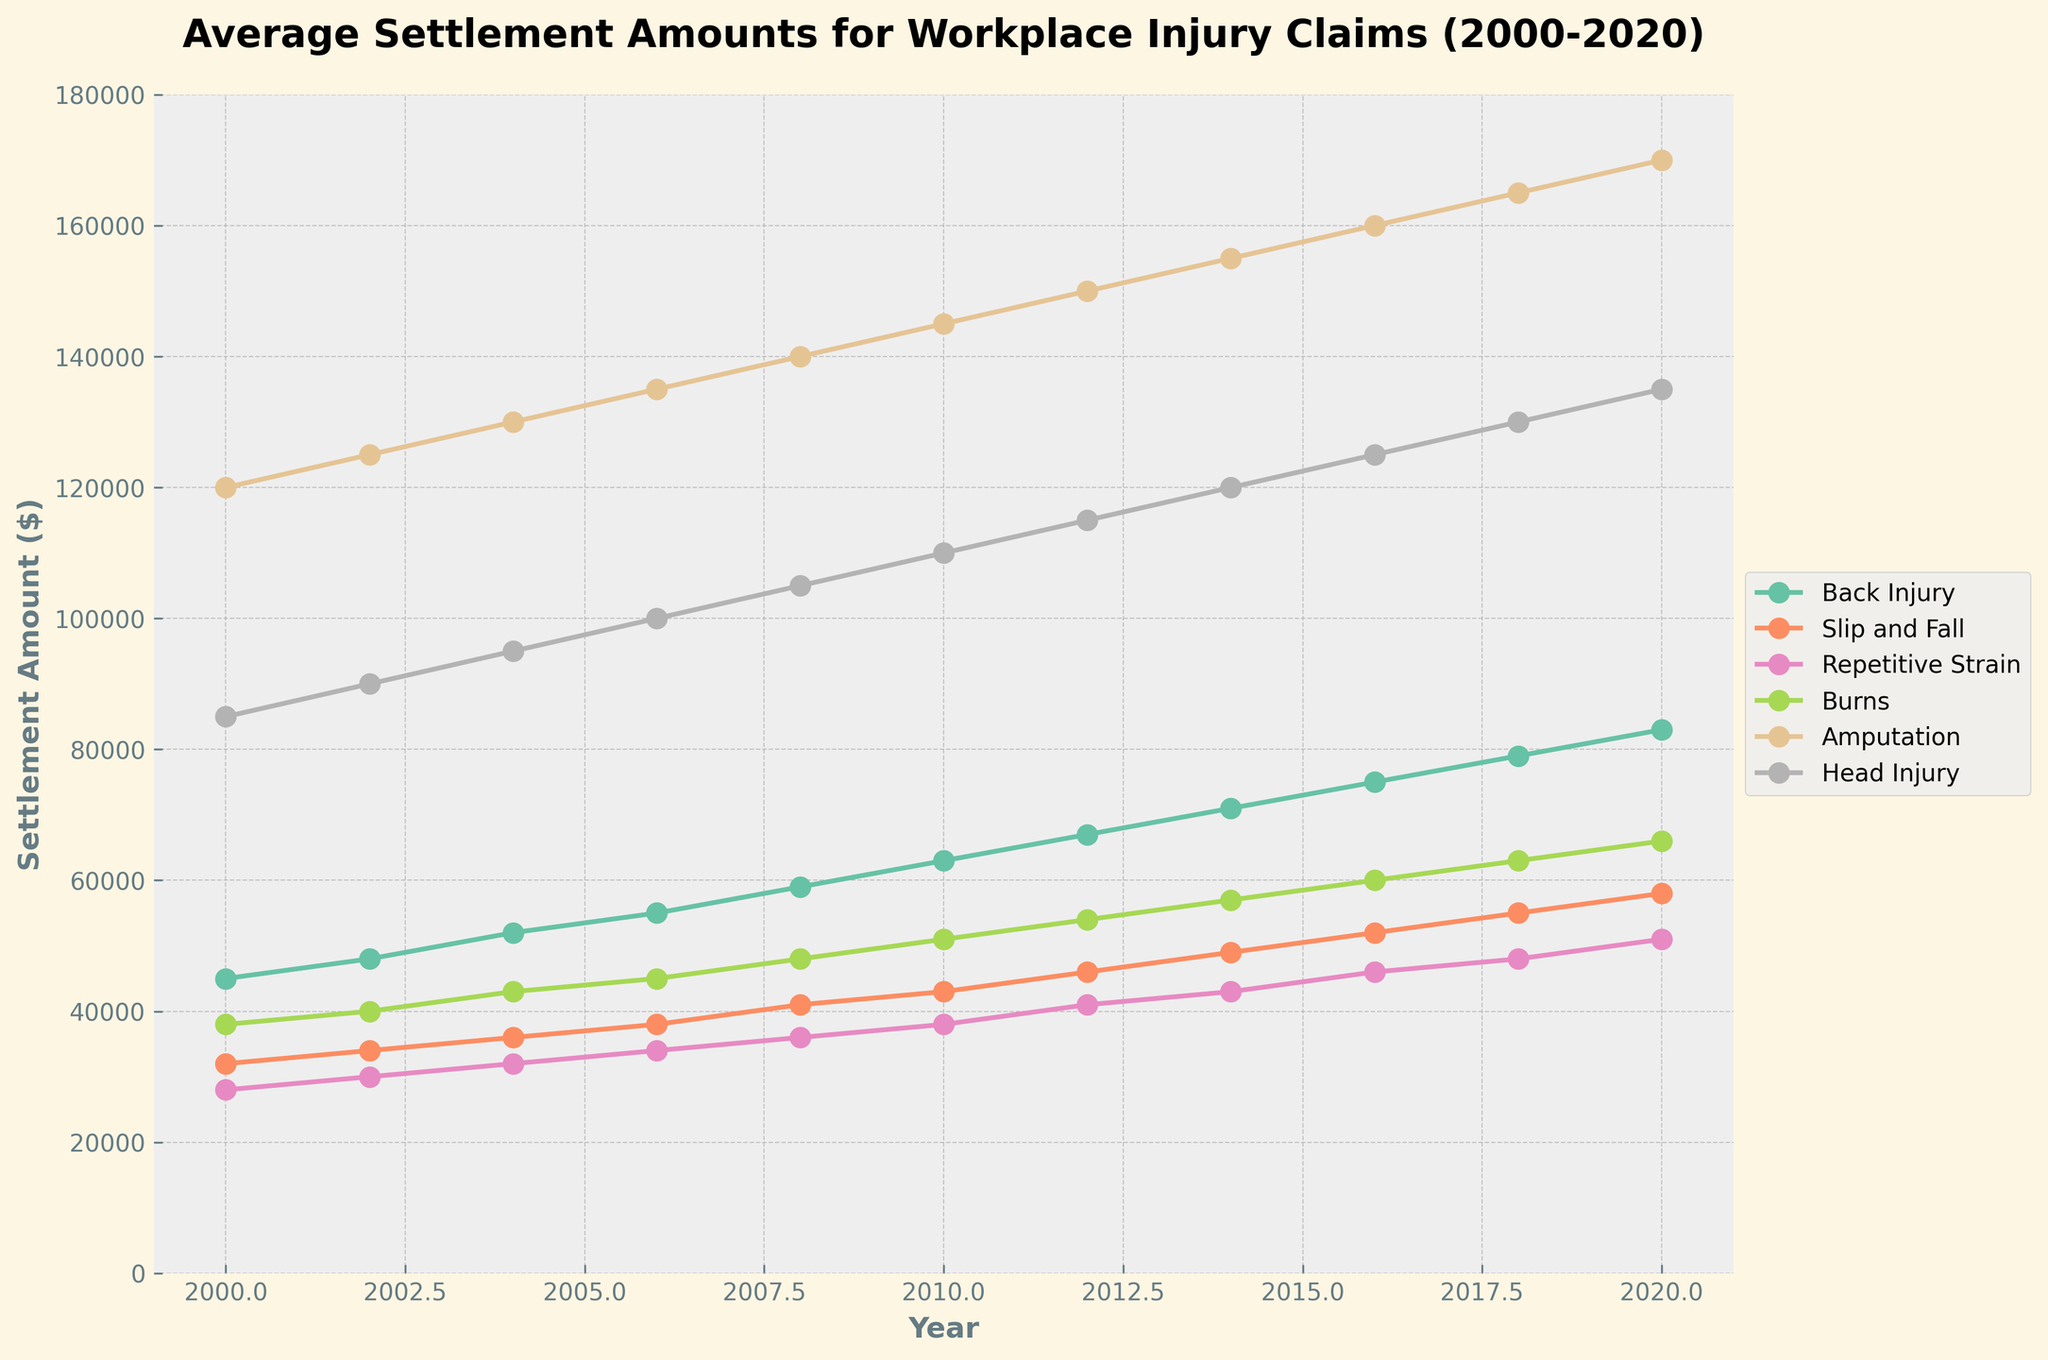Which type of injury had the highest average settlement amount in 2020? In 2020, look at the lines to identify the highest point. The Amputation category is the highest.
Answer: Amputation How did the average settlement amount for Slip and Fall injuries change from 2010 to 2020? Find the values for Slip and Fall in 2010 and 2020. In 2010, it was $43,000, and in 2020, it was $58,000. The change is $58,000 - $43,000 = $15,000.
Answer: Increased by $15,000 Which injury type had the least increase in average settlement amounts between 2000 and 2020? Calculate the difference between 2020 and 2000 for each injury type. The differences are: Back Injury: $83,000 - $45,000 = $38,000; Slip and Fall: $58,000 - $32,000 = $26,000; Repetitive Strain: $51,000 - $28,000 = $23,000; Burns: $66,000 - $38,000 = $28,000; Amputation: $170,000 - $120,000 = $50,000; Head Injury: $135,000 - $85,000 = $50,000. Repetitive Strain had the smallest increase ($23,000).
Answer: Repetitive Strain What is the average settlement amount for Back Injury claims over the entire period? Find the values for Back Injury and calculate the average: ($45,000 + $48,000 + $52,000 + $55,000 + $59,000 + $63,000 + $67,000 + $71,000 + $75,000 + $79,000 + $83,000) / 11 = $62,000.
Answer: $62,000 Compare the trends of Back Injury and Head Injury claims from 2000 to 2020. Both Back Injury and Head Injury show an increasing trend. Back Injury starts at $45,000 and ends at $83,000. Head Injury starts at $85,000 and ends at $135,000, maintaining higher settlement amounts but increasing less steeply.
Answer: Both increased; Head Injury had higher settlement amounts By how much did the average settlement amount for Burns increase from 2006 to 2014? Identify the values for Burns in 2006 and 2014. For 2006, it was $45,000 and for 2014 it was $57,000. Calculate the difference: $57,000 - $45,000 = $12,000.
Answer: $12,000 Which injury types had settlement amounts greater than $100,000 in 2018? Identify the values for each injury type in 2018. Head Injury ($130,000) and Amputation ($165,000) are greater than $100,000.
Answer: Head Injury, Amputation What is the combined settlement amount for Amputation and Head Injury claims in 2016? Identify the values for 2016. Amputation: $160,000, Head Injury: $125,000. Sum them up: $160,000 + $125,000 = $285,000.
Answer: $285,000 How does the rate of increase for Back Injury settlements compare to Repetitive Strain from 2000 to 2020? Calculate the difference for both Back Injury and Repetitive Strain. The difference for Back Injury is $83,000 - $45,000 = $38,000. For Repetitive Strain, it's $51,000 - $28,000 = $23,000. Back Injury settlements increased more.
Answer: Back Injury increased more What is the overall trend in average settlement amounts for all injury types from 2000 to 2020? All injury types show an increasing trend in average settlement amounts over the time period.
Answer: Increasing 